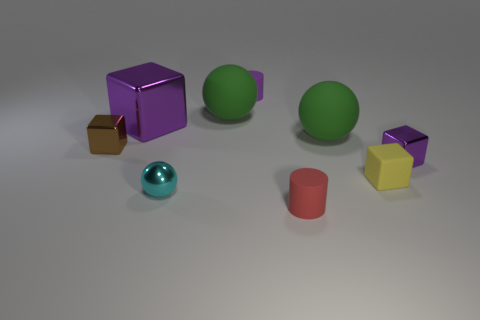Subtract all small brown blocks. How many blocks are left? 3 Subtract all yellow cylinders. How many purple blocks are left? 2 Add 1 tiny rubber cubes. How many objects exist? 10 Subtract 1 spheres. How many spheres are left? 2 Subtract all brown cubes. How many cubes are left? 3 Subtract all blocks. How many objects are left? 5 Subtract all tiny red cubes. Subtract all balls. How many objects are left? 6 Add 6 matte cubes. How many matte cubes are left? 7 Add 7 tiny gray things. How many tiny gray things exist? 7 Subtract 0 brown balls. How many objects are left? 9 